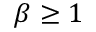<formula> <loc_0><loc_0><loc_500><loc_500>\beta \geq 1</formula> 